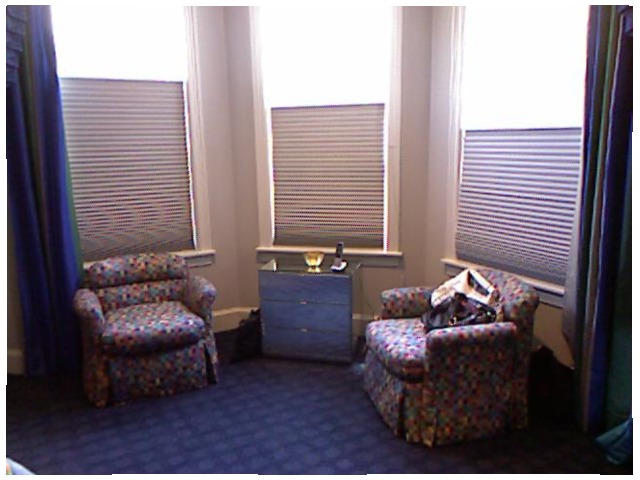<image>
Is there a phone on the blind? No. The phone is not positioned on the blind. They may be near each other, but the phone is not supported by or resting on top of the blind. Where is the beam in relation to the table? Is it behind the table? Yes. From this viewpoint, the beam is positioned behind the table, with the table partially or fully occluding the beam. Is there a sofa chair next to the sofa chair? Yes. The sofa chair is positioned adjacent to the sofa chair, located nearby in the same general area. 